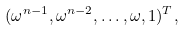Convert formula to latex. <formula><loc_0><loc_0><loc_500><loc_500>( \omega ^ { n - 1 } , \omega ^ { n - 2 } , \dots , \omega , 1 ) ^ { T } ,</formula> 